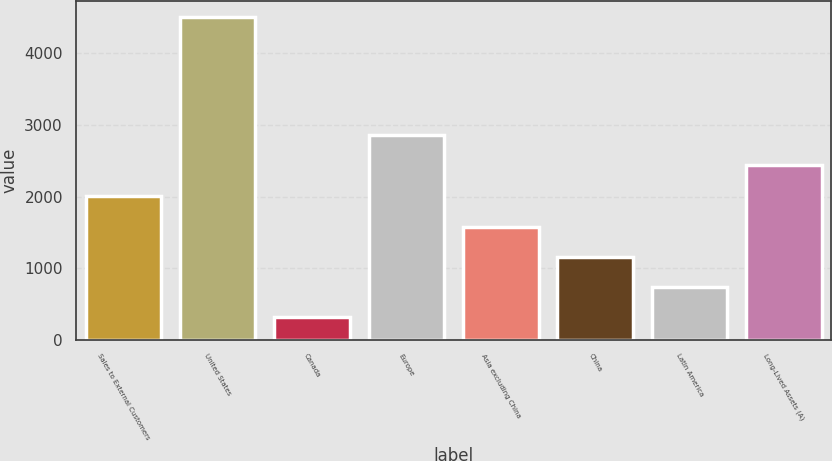Convert chart to OTSL. <chart><loc_0><loc_0><loc_500><loc_500><bar_chart><fcel>Sales to External Customers<fcel>United States<fcel>Canada<fcel>Europe<fcel>Asia excluding China<fcel>China<fcel>Latin America<fcel>Long-Lived Assets (A)<nl><fcel>2014<fcel>4507.6<fcel>311.4<fcel>2853.24<fcel>1570.26<fcel>1150.64<fcel>731.02<fcel>2433.62<nl></chart> 